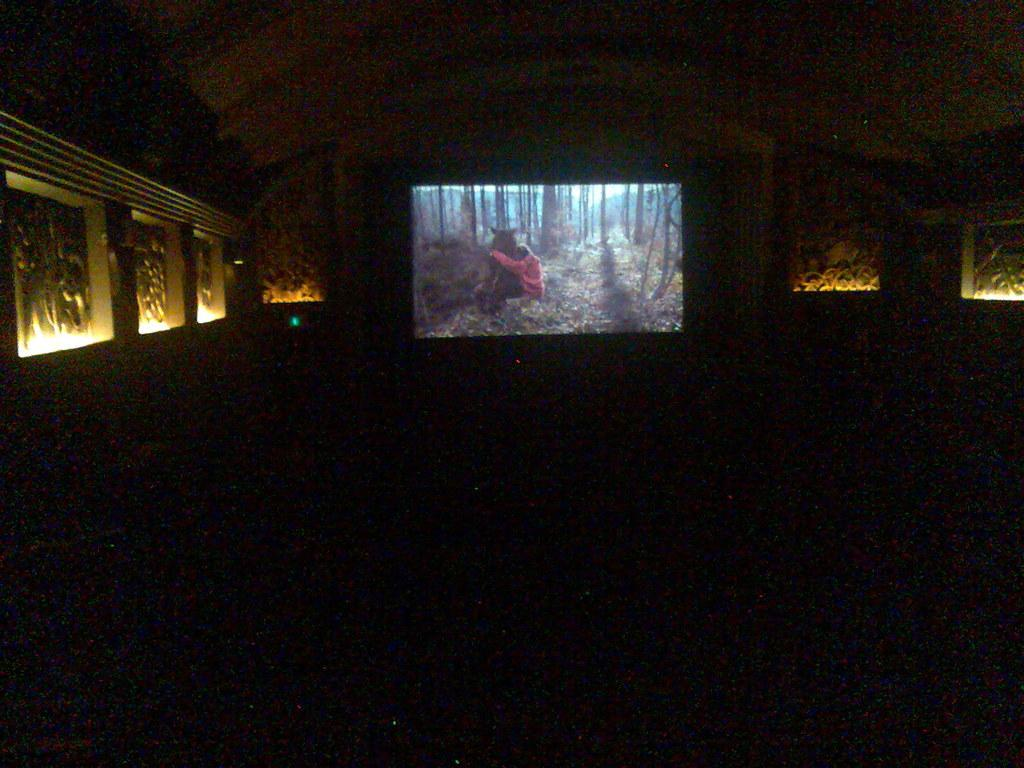What is the main subject of the picture? The main subject of the picture is an image on a screen. What can be seen on the wall in the picture? There is a designed wall in the picture. What additional features are present near the designed wall? There are lights on either side of the designed wall. What type of button is being pressed by the head in the image? There is no button or head present in the image; it only features an image on a screen, a designed wall, and lights on either side of the wall. 